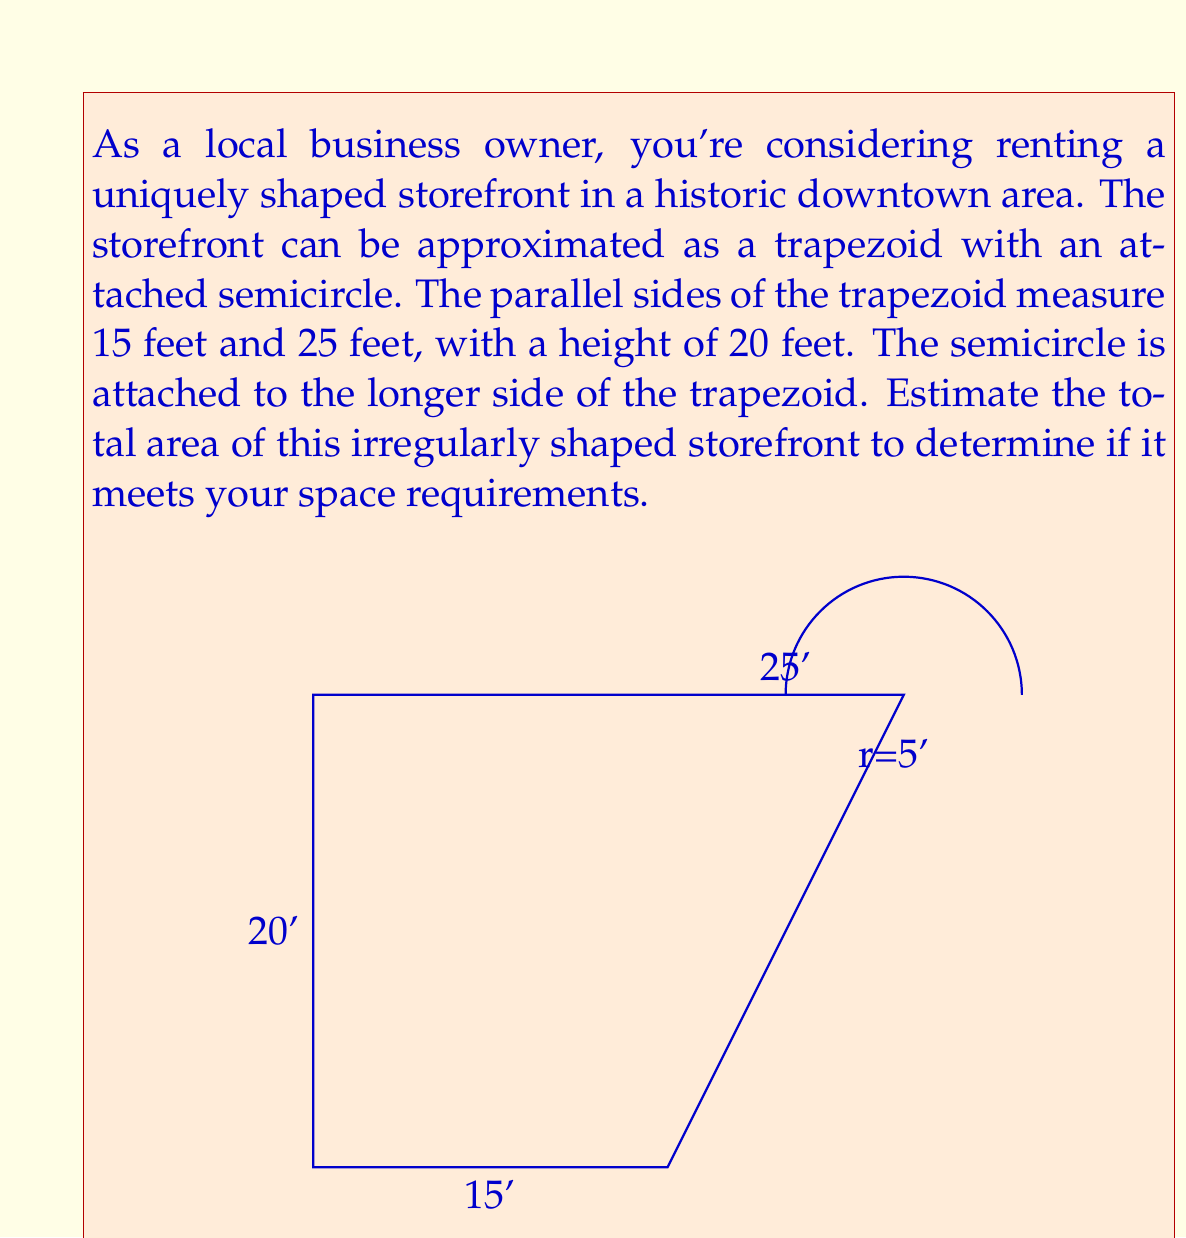Can you solve this math problem? To solve this problem, we'll break it down into two parts: the area of the trapezoid and the area of the semicircle.

1. Area of the trapezoid:
   The formula for the area of a trapezoid is:
   $$A_{trapezoid} = \frac{1}{2}(b_1 + b_2)h$$
   where $b_1$ and $b_2$ are the parallel sides and $h$ is the height.

   Substituting the given values:
   $$A_{trapezoid} = \frac{1}{2}(15 + 25) \times 20 = \frac{1}{2} \times 40 \times 20 = 400 \text{ sq ft}$$

2. Area of the semicircle:
   The formula for the area of a semicircle is:
   $$A_{semicircle} = \frac{1}{2} \pi r^2$$
   where $r$ is the radius.

   The radius of the semicircle is half the difference between the parallel sides of the trapezoid:
   $$r = \frac{25 - 15}{2} = 5 \text{ ft}$$

   Now we can calculate the area of the semicircle:
   $$A_{semicircle} = \frac{1}{2} \pi (5)^2 = \frac{25\pi}{2} \approx 39.27 \text{ sq ft}$$

3. Total area:
   The total area is the sum of the trapezoid and semicircle areas:
   $$A_{total} = A_{trapezoid} + A_{semicircle} = 400 + \frac{25\pi}{2} \approx 439.27 \text{ sq ft}$$

Therefore, the estimated total area of the irregularly shaped storefront is approximately 439.27 square feet.
Answer: $$439.27 \text{ sq ft}$$ (rounded to two decimal places) 